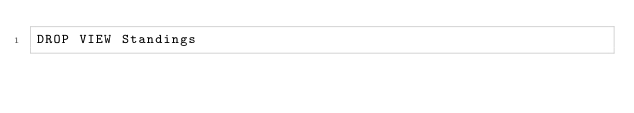Convert code to text. <code><loc_0><loc_0><loc_500><loc_500><_SQL_>DROP VIEW Standings</code> 